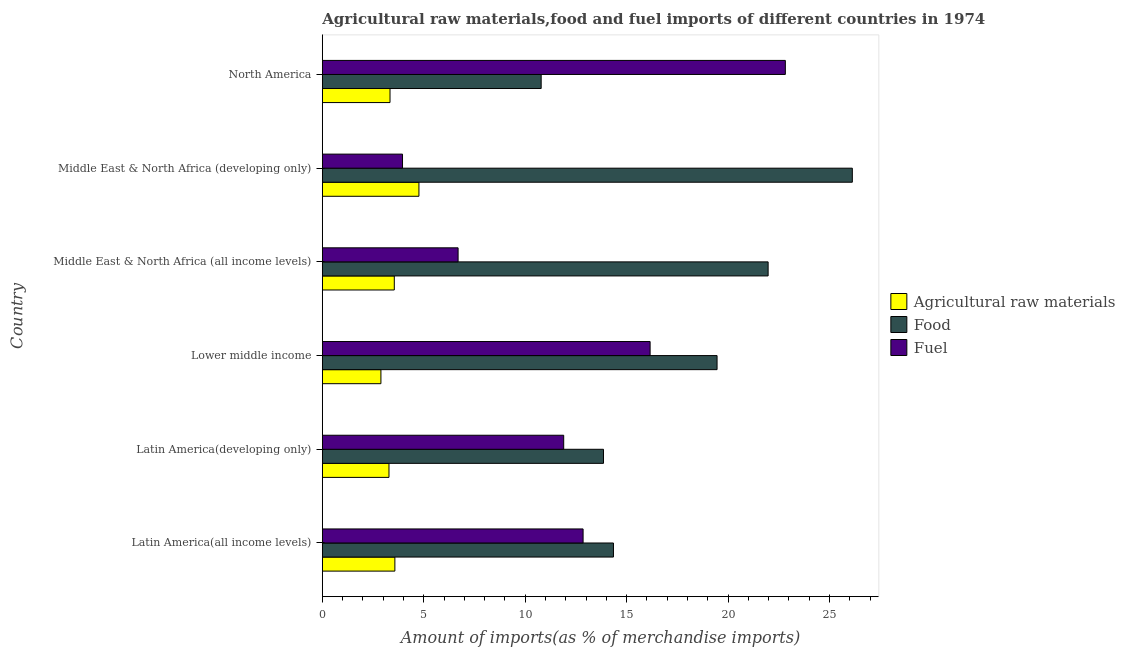How many groups of bars are there?
Keep it short and to the point. 6. Are the number of bars per tick equal to the number of legend labels?
Provide a short and direct response. Yes. Are the number of bars on each tick of the Y-axis equal?
Your answer should be compact. Yes. What is the percentage of raw materials imports in Middle East & North Africa (all income levels)?
Your response must be concise. 3.55. Across all countries, what is the maximum percentage of raw materials imports?
Your answer should be very brief. 4.76. Across all countries, what is the minimum percentage of raw materials imports?
Offer a very short reply. 2.89. In which country was the percentage of raw materials imports maximum?
Provide a short and direct response. Middle East & North Africa (developing only). What is the total percentage of food imports in the graph?
Give a very brief answer. 106.57. What is the difference between the percentage of raw materials imports in Middle East & North Africa (all income levels) and that in Middle East & North Africa (developing only)?
Your answer should be compact. -1.22. What is the difference between the percentage of fuel imports in North America and the percentage of raw materials imports in Latin America(all income levels)?
Keep it short and to the point. 19.25. What is the average percentage of food imports per country?
Provide a succinct answer. 17.76. What is the difference between the percentage of raw materials imports and percentage of food imports in Middle East & North Africa (developing only)?
Ensure brevity in your answer.  -21.37. In how many countries, is the percentage of raw materials imports greater than 4 %?
Make the answer very short. 1. Is the percentage of raw materials imports in Latin America(developing only) less than that in North America?
Make the answer very short. Yes. What is the difference between the highest and the second highest percentage of food imports?
Your answer should be compact. 4.15. What is the difference between the highest and the lowest percentage of raw materials imports?
Keep it short and to the point. 1.87. What does the 2nd bar from the top in Middle East & North Africa (developing only) represents?
Make the answer very short. Food. What does the 2nd bar from the bottom in Middle East & North Africa (developing only) represents?
Your answer should be very brief. Food. How many bars are there?
Give a very brief answer. 18. How many countries are there in the graph?
Your answer should be compact. 6. Are the values on the major ticks of X-axis written in scientific E-notation?
Your answer should be very brief. No. Does the graph contain any zero values?
Your answer should be compact. No. Does the graph contain grids?
Provide a short and direct response. No. Where does the legend appear in the graph?
Give a very brief answer. Center right. How are the legend labels stacked?
Your answer should be compact. Vertical. What is the title of the graph?
Your answer should be compact. Agricultural raw materials,food and fuel imports of different countries in 1974. Does "Male employers" appear as one of the legend labels in the graph?
Offer a very short reply. No. What is the label or title of the X-axis?
Give a very brief answer. Amount of imports(as % of merchandise imports). What is the label or title of the Y-axis?
Offer a very short reply. Country. What is the Amount of imports(as % of merchandise imports) in Agricultural raw materials in Latin America(all income levels)?
Offer a terse response. 3.58. What is the Amount of imports(as % of merchandise imports) in Food in Latin America(all income levels)?
Offer a terse response. 14.35. What is the Amount of imports(as % of merchandise imports) in Fuel in Latin America(all income levels)?
Provide a short and direct response. 12.86. What is the Amount of imports(as % of merchandise imports) in Agricultural raw materials in Latin America(developing only)?
Provide a short and direct response. 3.29. What is the Amount of imports(as % of merchandise imports) of Food in Latin America(developing only)?
Give a very brief answer. 13.86. What is the Amount of imports(as % of merchandise imports) in Fuel in Latin America(developing only)?
Offer a terse response. 11.9. What is the Amount of imports(as % of merchandise imports) in Agricultural raw materials in Lower middle income?
Offer a very short reply. 2.89. What is the Amount of imports(as % of merchandise imports) of Food in Lower middle income?
Keep it short and to the point. 19.46. What is the Amount of imports(as % of merchandise imports) in Fuel in Lower middle income?
Your response must be concise. 16.16. What is the Amount of imports(as % of merchandise imports) of Agricultural raw materials in Middle East & North Africa (all income levels)?
Offer a very short reply. 3.55. What is the Amount of imports(as % of merchandise imports) in Food in Middle East & North Africa (all income levels)?
Keep it short and to the point. 21.98. What is the Amount of imports(as % of merchandise imports) in Fuel in Middle East & North Africa (all income levels)?
Offer a very short reply. 6.69. What is the Amount of imports(as % of merchandise imports) of Agricultural raw materials in Middle East & North Africa (developing only)?
Ensure brevity in your answer.  4.76. What is the Amount of imports(as % of merchandise imports) in Food in Middle East & North Africa (developing only)?
Keep it short and to the point. 26.13. What is the Amount of imports(as % of merchandise imports) in Fuel in Middle East & North Africa (developing only)?
Your answer should be compact. 3.95. What is the Amount of imports(as % of merchandise imports) of Agricultural raw materials in North America?
Keep it short and to the point. 3.34. What is the Amount of imports(as % of merchandise imports) of Food in North America?
Your answer should be very brief. 10.79. What is the Amount of imports(as % of merchandise imports) in Fuel in North America?
Provide a succinct answer. 22.83. Across all countries, what is the maximum Amount of imports(as % of merchandise imports) of Agricultural raw materials?
Ensure brevity in your answer.  4.76. Across all countries, what is the maximum Amount of imports(as % of merchandise imports) in Food?
Ensure brevity in your answer.  26.13. Across all countries, what is the maximum Amount of imports(as % of merchandise imports) of Fuel?
Provide a succinct answer. 22.83. Across all countries, what is the minimum Amount of imports(as % of merchandise imports) in Agricultural raw materials?
Make the answer very short. 2.89. Across all countries, what is the minimum Amount of imports(as % of merchandise imports) of Food?
Your response must be concise. 10.79. Across all countries, what is the minimum Amount of imports(as % of merchandise imports) in Fuel?
Your answer should be very brief. 3.95. What is the total Amount of imports(as % of merchandise imports) of Agricultural raw materials in the graph?
Offer a terse response. 21.4. What is the total Amount of imports(as % of merchandise imports) of Food in the graph?
Keep it short and to the point. 106.57. What is the total Amount of imports(as % of merchandise imports) of Fuel in the graph?
Provide a short and direct response. 74.39. What is the difference between the Amount of imports(as % of merchandise imports) in Agricultural raw materials in Latin America(all income levels) and that in Latin America(developing only)?
Your answer should be compact. 0.29. What is the difference between the Amount of imports(as % of merchandise imports) of Food in Latin America(all income levels) and that in Latin America(developing only)?
Offer a very short reply. 0.49. What is the difference between the Amount of imports(as % of merchandise imports) of Fuel in Latin America(all income levels) and that in Latin America(developing only)?
Provide a short and direct response. 0.96. What is the difference between the Amount of imports(as % of merchandise imports) in Agricultural raw materials in Latin America(all income levels) and that in Lower middle income?
Provide a short and direct response. 0.69. What is the difference between the Amount of imports(as % of merchandise imports) in Food in Latin America(all income levels) and that in Lower middle income?
Offer a terse response. -5.11. What is the difference between the Amount of imports(as % of merchandise imports) in Fuel in Latin America(all income levels) and that in Lower middle income?
Give a very brief answer. -3.3. What is the difference between the Amount of imports(as % of merchandise imports) in Agricultural raw materials in Latin America(all income levels) and that in Middle East & North Africa (all income levels)?
Offer a terse response. 0.03. What is the difference between the Amount of imports(as % of merchandise imports) in Food in Latin America(all income levels) and that in Middle East & North Africa (all income levels)?
Offer a terse response. -7.63. What is the difference between the Amount of imports(as % of merchandise imports) of Fuel in Latin America(all income levels) and that in Middle East & North Africa (all income levels)?
Your answer should be very brief. 6.16. What is the difference between the Amount of imports(as % of merchandise imports) of Agricultural raw materials in Latin America(all income levels) and that in Middle East & North Africa (developing only)?
Ensure brevity in your answer.  -1.19. What is the difference between the Amount of imports(as % of merchandise imports) of Food in Latin America(all income levels) and that in Middle East & North Africa (developing only)?
Your answer should be very brief. -11.78. What is the difference between the Amount of imports(as % of merchandise imports) of Fuel in Latin America(all income levels) and that in Middle East & North Africa (developing only)?
Your response must be concise. 8.9. What is the difference between the Amount of imports(as % of merchandise imports) in Agricultural raw materials in Latin America(all income levels) and that in North America?
Give a very brief answer. 0.24. What is the difference between the Amount of imports(as % of merchandise imports) in Food in Latin America(all income levels) and that in North America?
Provide a succinct answer. 3.56. What is the difference between the Amount of imports(as % of merchandise imports) of Fuel in Latin America(all income levels) and that in North America?
Your response must be concise. -9.97. What is the difference between the Amount of imports(as % of merchandise imports) of Agricultural raw materials in Latin America(developing only) and that in Lower middle income?
Your answer should be compact. 0.4. What is the difference between the Amount of imports(as % of merchandise imports) of Food in Latin America(developing only) and that in Lower middle income?
Keep it short and to the point. -5.6. What is the difference between the Amount of imports(as % of merchandise imports) in Fuel in Latin America(developing only) and that in Lower middle income?
Offer a terse response. -4.26. What is the difference between the Amount of imports(as % of merchandise imports) of Agricultural raw materials in Latin America(developing only) and that in Middle East & North Africa (all income levels)?
Provide a short and direct response. -0.26. What is the difference between the Amount of imports(as % of merchandise imports) of Food in Latin America(developing only) and that in Middle East & North Africa (all income levels)?
Your answer should be compact. -8.12. What is the difference between the Amount of imports(as % of merchandise imports) of Fuel in Latin America(developing only) and that in Middle East & North Africa (all income levels)?
Offer a terse response. 5.21. What is the difference between the Amount of imports(as % of merchandise imports) of Agricultural raw materials in Latin America(developing only) and that in Middle East & North Africa (developing only)?
Give a very brief answer. -1.48. What is the difference between the Amount of imports(as % of merchandise imports) in Food in Latin America(developing only) and that in Middle East & North Africa (developing only)?
Give a very brief answer. -12.27. What is the difference between the Amount of imports(as % of merchandise imports) in Fuel in Latin America(developing only) and that in Middle East & North Africa (developing only)?
Ensure brevity in your answer.  7.95. What is the difference between the Amount of imports(as % of merchandise imports) in Agricultural raw materials in Latin America(developing only) and that in North America?
Make the answer very short. -0.05. What is the difference between the Amount of imports(as % of merchandise imports) of Food in Latin America(developing only) and that in North America?
Ensure brevity in your answer.  3.07. What is the difference between the Amount of imports(as % of merchandise imports) in Fuel in Latin America(developing only) and that in North America?
Give a very brief answer. -10.93. What is the difference between the Amount of imports(as % of merchandise imports) of Agricultural raw materials in Lower middle income and that in Middle East & North Africa (all income levels)?
Offer a very short reply. -0.66. What is the difference between the Amount of imports(as % of merchandise imports) of Food in Lower middle income and that in Middle East & North Africa (all income levels)?
Keep it short and to the point. -2.52. What is the difference between the Amount of imports(as % of merchandise imports) in Fuel in Lower middle income and that in Middle East & North Africa (all income levels)?
Your response must be concise. 9.47. What is the difference between the Amount of imports(as % of merchandise imports) in Agricultural raw materials in Lower middle income and that in Middle East & North Africa (developing only)?
Provide a short and direct response. -1.87. What is the difference between the Amount of imports(as % of merchandise imports) of Food in Lower middle income and that in Middle East & North Africa (developing only)?
Your answer should be very brief. -6.67. What is the difference between the Amount of imports(as % of merchandise imports) in Fuel in Lower middle income and that in Middle East & North Africa (developing only)?
Keep it short and to the point. 12.21. What is the difference between the Amount of imports(as % of merchandise imports) of Agricultural raw materials in Lower middle income and that in North America?
Your response must be concise. -0.45. What is the difference between the Amount of imports(as % of merchandise imports) of Food in Lower middle income and that in North America?
Ensure brevity in your answer.  8.67. What is the difference between the Amount of imports(as % of merchandise imports) in Fuel in Lower middle income and that in North America?
Your answer should be compact. -6.67. What is the difference between the Amount of imports(as % of merchandise imports) in Agricultural raw materials in Middle East & North Africa (all income levels) and that in Middle East & North Africa (developing only)?
Your answer should be very brief. -1.21. What is the difference between the Amount of imports(as % of merchandise imports) of Food in Middle East & North Africa (all income levels) and that in Middle East & North Africa (developing only)?
Your response must be concise. -4.15. What is the difference between the Amount of imports(as % of merchandise imports) of Fuel in Middle East & North Africa (all income levels) and that in Middle East & North Africa (developing only)?
Your response must be concise. 2.74. What is the difference between the Amount of imports(as % of merchandise imports) of Agricultural raw materials in Middle East & North Africa (all income levels) and that in North America?
Give a very brief answer. 0.21. What is the difference between the Amount of imports(as % of merchandise imports) of Food in Middle East & North Africa (all income levels) and that in North America?
Ensure brevity in your answer.  11.19. What is the difference between the Amount of imports(as % of merchandise imports) in Fuel in Middle East & North Africa (all income levels) and that in North America?
Your answer should be compact. -16.13. What is the difference between the Amount of imports(as % of merchandise imports) of Agricultural raw materials in Middle East & North Africa (developing only) and that in North America?
Provide a succinct answer. 1.43. What is the difference between the Amount of imports(as % of merchandise imports) of Food in Middle East & North Africa (developing only) and that in North America?
Offer a terse response. 15.34. What is the difference between the Amount of imports(as % of merchandise imports) of Fuel in Middle East & North Africa (developing only) and that in North America?
Offer a very short reply. -18.87. What is the difference between the Amount of imports(as % of merchandise imports) in Agricultural raw materials in Latin America(all income levels) and the Amount of imports(as % of merchandise imports) in Food in Latin America(developing only)?
Your answer should be compact. -10.28. What is the difference between the Amount of imports(as % of merchandise imports) in Agricultural raw materials in Latin America(all income levels) and the Amount of imports(as % of merchandise imports) in Fuel in Latin America(developing only)?
Provide a short and direct response. -8.32. What is the difference between the Amount of imports(as % of merchandise imports) of Food in Latin America(all income levels) and the Amount of imports(as % of merchandise imports) of Fuel in Latin America(developing only)?
Your answer should be compact. 2.45. What is the difference between the Amount of imports(as % of merchandise imports) of Agricultural raw materials in Latin America(all income levels) and the Amount of imports(as % of merchandise imports) of Food in Lower middle income?
Provide a short and direct response. -15.88. What is the difference between the Amount of imports(as % of merchandise imports) of Agricultural raw materials in Latin America(all income levels) and the Amount of imports(as % of merchandise imports) of Fuel in Lower middle income?
Offer a terse response. -12.58. What is the difference between the Amount of imports(as % of merchandise imports) in Food in Latin America(all income levels) and the Amount of imports(as % of merchandise imports) in Fuel in Lower middle income?
Offer a terse response. -1.81. What is the difference between the Amount of imports(as % of merchandise imports) in Agricultural raw materials in Latin America(all income levels) and the Amount of imports(as % of merchandise imports) in Food in Middle East & North Africa (all income levels)?
Make the answer very short. -18.4. What is the difference between the Amount of imports(as % of merchandise imports) in Agricultural raw materials in Latin America(all income levels) and the Amount of imports(as % of merchandise imports) in Fuel in Middle East & North Africa (all income levels)?
Provide a succinct answer. -3.12. What is the difference between the Amount of imports(as % of merchandise imports) of Food in Latin America(all income levels) and the Amount of imports(as % of merchandise imports) of Fuel in Middle East & North Africa (all income levels)?
Your response must be concise. 7.66. What is the difference between the Amount of imports(as % of merchandise imports) in Agricultural raw materials in Latin America(all income levels) and the Amount of imports(as % of merchandise imports) in Food in Middle East & North Africa (developing only)?
Provide a short and direct response. -22.55. What is the difference between the Amount of imports(as % of merchandise imports) of Agricultural raw materials in Latin America(all income levels) and the Amount of imports(as % of merchandise imports) of Fuel in Middle East & North Africa (developing only)?
Keep it short and to the point. -0.38. What is the difference between the Amount of imports(as % of merchandise imports) of Food in Latin America(all income levels) and the Amount of imports(as % of merchandise imports) of Fuel in Middle East & North Africa (developing only)?
Your response must be concise. 10.4. What is the difference between the Amount of imports(as % of merchandise imports) in Agricultural raw materials in Latin America(all income levels) and the Amount of imports(as % of merchandise imports) in Food in North America?
Provide a succinct answer. -7.21. What is the difference between the Amount of imports(as % of merchandise imports) of Agricultural raw materials in Latin America(all income levels) and the Amount of imports(as % of merchandise imports) of Fuel in North America?
Make the answer very short. -19.25. What is the difference between the Amount of imports(as % of merchandise imports) in Food in Latin America(all income levels) and the Amount of imports(as % of merchandise imports) in Fuel in North America?
Give a very brief answer. -8.47. What is the difference between the Amount of imports(as % of merchandise imports) in Agricultural raw materials in Latin America(developing only) and the Amount of imports(as % of merchandise imports) in Food in Lower middle income?
Offer a terse response. -16.17. What is the difference between the Amount of imports(as % of merchandise imports) of Agricultural raw materials in Latin America(developing only) and the Amount of imports(as % of merchandise imports) of Fuel in Lower middle income?
Your answer should be very brief. -12.87. What is the difference between the Amount of imports(as % of merchandise imports) in Food in Latin America(developing only) and the Amount of imports(as % of merchandise imports) in Fuel in Lower middle income?
Give a very brief answer. -2.3. What is the difference between the Amount of imports(as % of merchandise imports) in Agricultural raw materials in Latin America(developing only) and the Amount of imports(as % of merchandise imports) in Food in Middle East & North Africa (all income levels)?
Give a very brief answer. -18.69. What is the difference between the Amount of imports(as % of merchandise imports) of Agricultural raw materials in Latin America(developing only) and the Amount of imports(as % of merchandise imports) of Fuel in Middle East & North Africa (all income levels)?
Keep it short and to the point. -3.41. What is the difference between the Amount of imports(as % of merchandise imports) in Food in Latin America(developing only) and the Amount of imports(as % of merchandise imports) in Fuel in Middle East & North Africa (all income levels)?
Offer a terse response. 7.17. What is the difference between the Amount of imports(as % of merchandise imports) of Agricultural raw materials in Latin America(developing only) and the Amount of imports(as % of merchandise imports) of Food in Middle East & North Africa (developing only)?
Provide a succinct answer. -22.84. What is the difference between the Amount of imports(as % of merchandise imports) of Agricultural raw materials in Latin America(developing only) and the Amount of imports(as % of merchandise imports) of Fuel in Middle East & North Africa (developing only)?
Your answer should be compact. -0.67. What is the difference between the Amount of imports(as % of merchandise imports) of Food in Latin America(developing only) and the Amount of imports(as % of merchandise imports) of Fuel in Middle East & North Africa (developing only)?
Your answer should be compact. 9.91. What is the difference between the Amount of imports(as % of merchandise imports) in Agricultural raw materials in Latin America(developing only) and the Amount of imports(as % of merchandise imports) in Food in North America?
Your answer should be very brief. -7.5. What is the difference between the Amount of imports(as % of merchandise imports) of Agricultural raw materials in Latin America(developing only) and the Amount of imports(as % of merchandise imports) of Fuel in North America?
Give a very brief answer. -19.54. What is the difference between the Amount of imports(as % of merchandise imports) in Food in Latin America(developing only) and the Amount of imports(as % of merchandise imports) in Fuel in North America?
Keep it short and to the point. -8.97. What is the difference between the Amount of imports(as % of merchandise imports) of Agricultural raw materials in Lower middle income and the Amount of imports(as % of merchandise imports) of Food in Middle East & North Africa (all income levels)?
Provide a short and direct response. -19.09. What is the difference between the Amount of imports(as % of merchandise imports) of Agricultural raw materials in Lower middle income and the Amount of imports(as % of merchandise imports) of Fuel in Middle East & North Africa (all income levels)?
Your response must be concise. -3.8. What is the difference between the Amount of imports(as % of merchandise imports) of Food in Lower middle income and the Amount of imports(as % of merchandise imports) of Fuel in Middle East & North Africa (all income levels)?
Keep it short and to the point. 12.77. What is the difference between the Amount of imports(as % of merchandise imports) of Agricultural raw materials in Lower middle income and the Amount of imports(as % of merchandise imports) of Food in Middle East & North Africa (developing only)?
Your answer should be compact. -23.24. What is the difference between the Amount of imports(as % of merchandise imports) of Agricultural raw materials in Lower middle income and the Amount of imports(as % of merchandise imports) of Fuel in Middle East & North Africa (developing only)?
Your answer should be very brief. -1.06. What is the difference between the Amount of imports(as % of merchandise imports) in Food in Lower middle income and the Amount of imports(as % of merchandise imports) in Fuel in Middle East & North Africa (developing only)?
Your answer should be compact. 15.51. What is the difference between the Amount of imports(as % of merchandise imports) of Agricultural raw materials in Lower middle income and the Amount of imports(as % of merchandise imports) of Food in North America?
Offer a very short reply. -7.9. What is the difference between the Amount of imports(as % of merchandise imports) in Agricultural raw materials in Lower middle income and the Amount of imports(as % of merchandise imports) in Fuel in North America?
Your answer should be compact. -19.94. What is the difference between the Amount of imports(as % of merchandise imports) in Food in Lower middle income and the Amount of imports(as % of merchandise imports) in Fuel in North America?
Keep it short and to the point. -3.37. What is the difference between the Amount of imports(as % of merchandise imports) in Agricultural raw materials in Middle East & North Africa (all income levels) and the Amount of imports(as % of merchandise imports) in Food in Middle East & North Africa (developing only)?
Your answer should be very brief. -22.58. What is the difference between the Amount of imports(as % of merchandise imports) in Agricultural raw materials in Middle East & North Africa (all income levels) and the Amount of imports(as % of merchandise imports) in Fuel in Middle East & North Africa (developing only)?
Give a very brief answer. -0.4. What is the difference between the Amount of imports(as % of merchandise imports) of Food in Middle East & North Africa (all income levels) and the Amount of imports(as % of merchandise imports) of Fuel in Middle East & North Africa (developing only)?
Give a very brief answer. 18.02. What is the difference between the Amount of imports(as % of merchandise imports) in Agricultural raw materials in Middle East & North Africa (all income levels) and the Amount of imports(as % of merchandise imports) in Food in North America?
Your answer should be very brief. -7.24. What is the difference between the Amount of imports(as % of merchandise imports) in Agricultural raw materials in Middle East & North Africa (all income levels) and the Amount of imports(as % of merchandise imports) in Fuel in North America?
Keep it short and to the point. -19.28. What is the difference between the Amount of imports(as % of merchandise imports) in Food in Middle East & North Africa (all income levels) and the Amount of imports(as % of merchandise imports) in Fuel in North America?
Your response must be concise. -0.85. What is the difference between the Amount of imports(as % of merchandise imports) of Agricultural raw materials in Middle East & North Africa (developing only) and the Amount of imports(as % of merchandise imports) of Food in North America?
Keep it short and to the point. -6.03. What is the difference between the Amount of imports(as % of merchandise imports) in Agricultural raw materials in Middle East & North Africa (developing only) and the Amount of imports(as % of merchandise imports) in Fuel in North America?
Your response must be concise. -18.06. What is the difference between the Amount of imports(as % of merchandise imports) of Food in Middle East & North Africa (developing only) and the Amount of imports(as % of merchandise imports) of Fuel in North America?
Provide a short and direct response. 3.3. What is the average Amount of imports(as % of merchandise imports) in Agricultural raw materials per country?
Offer a terse response. 3.57. What is the average Amount of imports(as % of merchandise imports) of Food per country?
Provide a succinct answer. 17.76. What is the average Amount of imports(as % of merchandise imports) in Fuel per country?
Your answer should be compact. 12.4. What is the difference between the Amount of imports(as % of merchandise imports) in Agricultural raw materials and Amount of imports(as % of merchandise imports) in Food in Latin America(all income levels)?
Provide a short and direct response. -10.78. What is the difference between the Amount of imports(as % of merchandise imports) of Agricultural raw materials and Amount of imports(as % of merchandise imports) of Fuel in Latin America(all income levels)?
Make the answer very short. -9.28. What is the difference between the Amount of imports(as % of merchandise imports) of Food and Amount of imports(as % of merchandise imports) of Fuel in Latin America(all income levels)?
Provide a short and direct response. 1.5. What is the difference between the Amount of imports(as % of merchandise imports) of Agricultural raw materials and Amount of imports(as % of merchandise imports) of Food in Latin America(developing only)?
Your answer should be very brief. -10.57. What is the difference between the Amount of imports(as % of merchandise imports) in Agricultural raw materials and Amount of imports(as % of merchandise imports) in Fuel in Latin America(developing only)?
Keep it short and to the point. -8.61. What is the difference between the Amount of imports(as % of merchandise imports) of Food and Amount of imports(as % of merchandise imports) of Fuel in Latin America(developing only)?
Keep it short and to the point. 1.96. What is the difference between the Amount of imports(as % of merchandise imports) in Agricultural raw materials and Amount of imports(as % of merchandise imports) in Food in Lower middle income?
Provide a short and direct response. -16.57. What is the difference between the Amount of imports(as % of merchandise imports) in Agricultural raw materials and Amount of imports(as % of merchandise imports) in Fuel in Lower middle income?
Provide a short and direct response. -13.27. What is the difference between the Amount of imports(as % of merchandise imports) in Food and Amount of imports(as % of merchandise imports) in Fuel in Lower middle income?
Make the answer very short. 3.3. What is the difference between the Amount of imports(as % of merchandise imports) of Agricultural raw materials and Amount of imports(as % of merchandise imports) of Food in Middle East & North Africa (all income levels)?
Give a very brief answer. -18.43. What is the difference between the Amount of imports(as % of merchandise imports) in Agricultural raw materials and Amount of imports(as % of merchandise imports) in Fuel in Middle East & North Africa (all income levels)?
Ensure brevity in your answer.  -3.15. What is the difference between the Amount of imports(as % of merchandise imports) of Food and Amount of imports(as % of merchandise imports) of Fuel in Middle East & North Africa (all income levels)?
Your answer should be compact. 15.28. What is the difference between the Amount of imports(as % of merchandise imports) in Agricultural raw materials and Amount of imports(as % of merchandise imports) in Food in Middle East & North Africa (developing only)?
Offer a very short reply. -21.37. What is the difference between the Amount of imports(as % of merchandise imports) in Agricultural raw materials and Amount of imports(as % of merchandise imports) in Fuel in Middle East & North Africa (developing only)?
Offer a terse response. 0.81. What is the difference between the Amount of imports(as % of merchandise imports) of Food and Amount of imports(as % of merchandise imports) of Fuel in Middle East & North Africa (developing only)?
Make the answer very short. 22.18. What is the difference between the Amount of imports(as % of merchandise imports) in Agricultural raw materials and Amount of imports(as % of merchandise imports) in Food in North America?
Make the answer very short. -7.45. What is the difference between the Amount of imports(as % of merchandise imports) in Agricultural raw materials and Amount of imports(as % of merchandise imports) in Fuel in North America?
Your answer should be very brief. -19.49. What is the difference between the Amount of imports(as % of merchandise imports) of Food and Amount of imports(as % of merchandise imports) of Fuel in North America?
Your answer should be very brief. -12.04. What is the ratio of the Amount of imports(as % of merchandise imports) of Agricultural raw materials in Latin America(all income levels) to that in Latin America(developing only)?
Your answer should be very brief. 1.09. What is the ratio of the Amount of imports(as % of merchandise imports) in Food in Latin America(all income levels) to that in Latin America(developing only)?
Ensure brevity in your answer.  1.04. What is the ratio of the Amount of imports(as % of merchandise imports) of Fuel in Latin America(all income levels) to that in Latin America(developing only)?
Your answer should be very brief. 1.08. What is the ratio of the Amount of imports(as % of merchandise imports) in Agricultural raw materials in Latin America(all income levels) to that in Lower middle income?
Provide a short and direct response. 1.24. What is the ratio of the Amount of imports(as % of merchandise imports) in Food in Latin America(all income levels) to that in Lower middle income?
Ensure brevity in your answer.  0.74. What is the ratio of the Amount of imports(as % of merchandise imports) in Fuel in Latin America(all income levels) to that in Lower middle income?
Make the answer very short. 0.8. What is the ratio of the Amount of imports(as % of merchandise imports) of Agricultural raw materials in Latin America(all income levels) to that in Middle East & North Africa (all income levels)?
Give a very brief answer. 1.01. What is the ratio of the Amount of imports(as % of merchandise imports) in Food in Latin America(all income levels) to that in Middle East & North Africa (all income levels)?
Provide a succinct answer. 0.65. What is the ratio of the Amount of imports(as % of merchandise imports) in Fuel in Latin America(all income levels) to that in Middle East & North Africa (all income levels)?
Ensure brevity in your answer.  1.92. What is the ratio of the Amount of imports(as % of merchandise imports) of Agricultural raw materials in Latin America(all income levels) to that in Middle East & North Africa (developing only)?
Your answer should be very brief. 0.75. What is the ratio of the Amount of imports(as % of merchandise imports) in Food in Latin America(all income levels) to that in Middle East & North Africa (developing only)?
Give a very brief answer. 0.55. What is the ratio of the Amount of imports(as % of merchandise imports) of Fuel in Latin America(all income levels) to that in Middle East & North Africa (developing only)?
Ensure brevity in your answer.  3.25. What is the ratio of the Amount of imports(as % of merchandise imports) of Agricultural raw materials in Latin America(all income levels) to that in North America?
Your answer should be compact. 1.07. What is the ratio of the Amount of imports(as % of merchandise imports) of Food in Latin America(all income levels) to that in North America?
Your answer should be very brief. 1.33. What is the ratio of the Amount of imports(as % of merchandise imports) in Fuel in Latin America(all income levels) to that in North America?
Provide a succinct answer. 0.56. What is the ratio of the Amount of imports(as % of merchandise imports) in Agricultural raw materials in Latin America(developing only) to that in Lower middle income?
Your answer should be very brief. 1.14. What is the ratio of the Amount of imports(as % of merchandise imports) in Food in Latin America(developing only) to that in Lower middle income?
Provide a succinct answer. 0.71. What is the ratio of the Amount of imports(as % of merchandise imports) of Fuel in Latin America(developing only) to that in Lower middle income?
Your response must be concise. 0.74. What is the ratio of the Amount of imports(as % of merchandise imports) in Agricultural raw materials in Latin America(developing only) to that in Middle East & North Africa (all income levels)?
Provide a short and direct response. 0.93. What is the ratio of the Amount of imports(as % of merchandise imports) of Food in Latin America(developing only) to that in Middle East & North Africa (all income levels)?
Offer a terse response. 0.63. What is the ratio of the Amount of imports(as % of merchandise imports) of Fuel in Latin America(developing only) to that in Middle East & North Africa (all income levels)?
Offer a very short reply. 1.78. What is the ratio of the Amount of imports(as % of merchandise imports) of Agricultural raw materials in Latin America(developing only) to that in Middle East & North Africa (developing only)?
Offer a very short reply. 0.69. What is the ratio of the Amount of imports(as % of merchandise imports) of Food in Latin America(developing only) to that in Middle East & North Africa (developing only)?
Provide a short and direct response. 0.53. What is the ratio of the Amount of imports(as % of merchandise imports) in Fuel in Latin America(developing only) to that in Middle East & North Africa (developing only)?
Keep it short and to the point. 3.01. What is the ratio of the Amount of imports(as % of merchandise imports) in Agricultural raw materials in Latin America(developing only) to that in North America?
Provide a succinct answer. 0.98. What is the ratio of the Amount of imports(as % of merchandise imports) in Food in Latin America(developing only) to that in North America?
Offer a very short reply. 1.28. What is the ratio of the Amount of imports(as % of merchandise imports) of Fuel in Latin America(developing only) to that in North America?
Ensure brevity in your answer.  0.52. What is the ratio of the Amount of imports(as % of merchandise imports) in Agricultural raw materials in Lower middle income to that in Middle East & North Africa (all income levels)?
Provide a short and direct response. 0.81. What is the ratio of the Amount of imports(as % of merchandise imports) of Food in Lower middle income to that in Middle East & North Africa (all income levels)?
Make the answer very short. 0.89. What is the ratio of the Amount of imports(as % of merchandise imports) in Fuel in Lower middle income to that in Middle East & North Africa (all income levels)?
Your response must be concise. 2.41. What is the ratio of the Amount of imports(as % of merchandise imports) in Agricultural raw materials in Lower middle income to that in Middle East & North Africa (developing only)?
Your response must be concise. 0.61. What is the ratio of the Amount of imports(as % of merchandise imports) in Food in Lower middle income to that in Middle East & North Africa (developing only)?
Provide a succinct answer. 0.74. What is the ratio of the Amount of imports(as % of merchandise imports) in Fuel in Lower middle income to that in Middle East & North Africa (developing only)?
Provide a short and direct response. 4.09. What is the ratio of the Amount of imports(as % of merchandise imports) of Agricultural raw materials in Lower middle income to that in North America?
Your answer should be compact. 0.87. What is the ratio of the Amount of imports(as % of merchandise imports) of Food in Lower middle income to that in North America?
Offer a very short reply. 1.8. What is the ratio of the Amount of imports(as % of merchandise imports) in Fuel in Lower middle income to that in North America?
Ensure brevity in your answer.  0.71. What is the ratio of the Amount of imports(as % of merchandise imports) in Agricultural raw materials in Middle East & North Africa (all income levels) to that in Middle East & North Africa (developing only)?
Your response must be concise. 0.74. What is the ratio of the Amount of imports(as % of merchandise imports) in Food in Middle East & North Africa (all income levels) to that in Middle East & North Africa (developing only)?
Give a very brief answer. 0.84. What is the ratio of the Amount of imports(as % of merchandise imports) of Fuel in Middle East & North Africa (all income levels) to that in Middle East & North Africa (developing only)?
Keep it short and to the point. 1.69. What is the ratio of the Amount of imports(as % of merchandise imports) in Agricultural raw materials in Middle East & North Africa (all income levels) to that in North America?
Your answer should be very brief. 1.06. What is the ratio of the Amount of imports(as % of merchandise imports) in Food in Middle East & North Africa (all income levels) to that in North America?
Ensure brevity in your answer.  2.04. What is the ratio of the Amount of imports(as % of merchandise imports) of Fuel in Middle East & North Africa (all income levels) to that in North America?
Keep it short and to the point. 0.29. What is the ratio of the Amount of imports(as % of merchandise imports) in Agricultural raw materials in Middle East & North Africa (developing only) to that in North America?
Offer a terse response. 1.43. What is the ratio of the Amount of imports(as % of merchandise imports) in Food in Middle East & North Africa (developing only) to that in North America?
Offer a very short reply. 2.42. What is the ratio of the Amount of imports(as % of merchandise imports) in Fuel in Middle East & North Africa (developing only) to that in North America?
Offer a very short reply. 0.17. What is the difference between the highest and the second highest Amount of imports(as % of merchandise imports) of Agricultural raw materials?
Offer a terse response. 1.19. What is the difference between the highest and the second highest Amount of imports(as % of merchandise imports) of Food?
Offer a terse response. 4.15. What is the difference between the highest and the second highest Amount of imports(as % of merchandise imports) of Fuel?
Offer a very short reply. 6.67. What is the difference between the highest and the lowest Amount of imports(as % of merchandise imports) of Agricultural raw materials?
Your answer should be compact. 1.87. What is the difference between the highest and the lowest Amount of imports(as % of merchandise imports) in Food?
Your answer should be compact. 15.34. What is the difference between the highest and the lowest Amount of imports(as % of merchandise imports) of Fuel?
Provide a succinct answer. 18.87. 